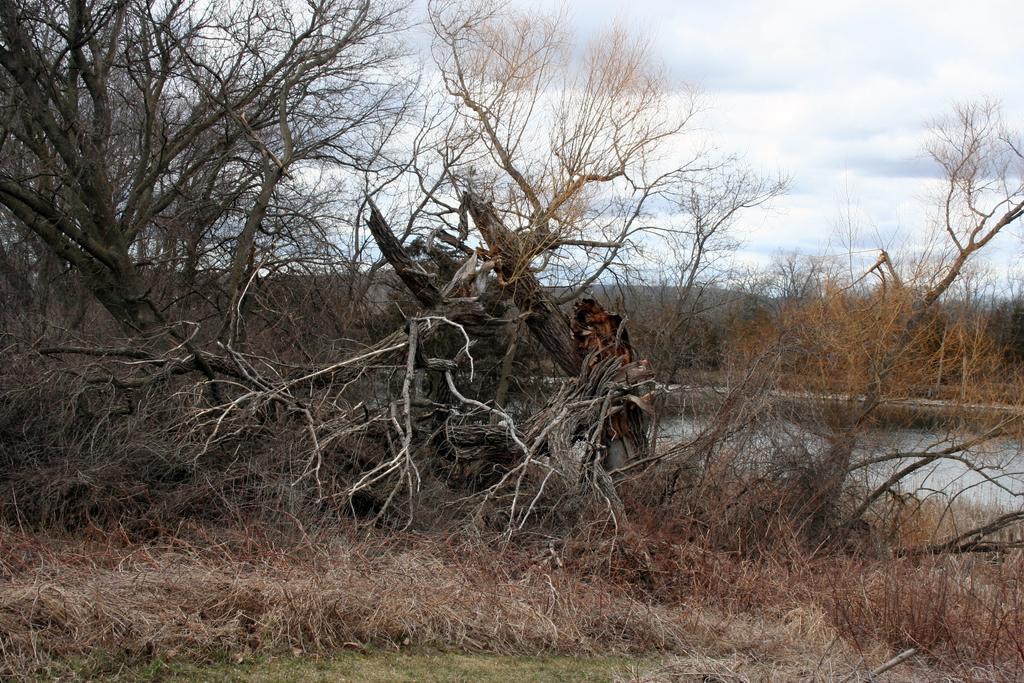Can you describe this image briefly? In the foreground of the picture there are dried trees, plants, twigs and grass. In the center of the picture there is a water body. In the background the trees and sky. Sky is cloudy. 